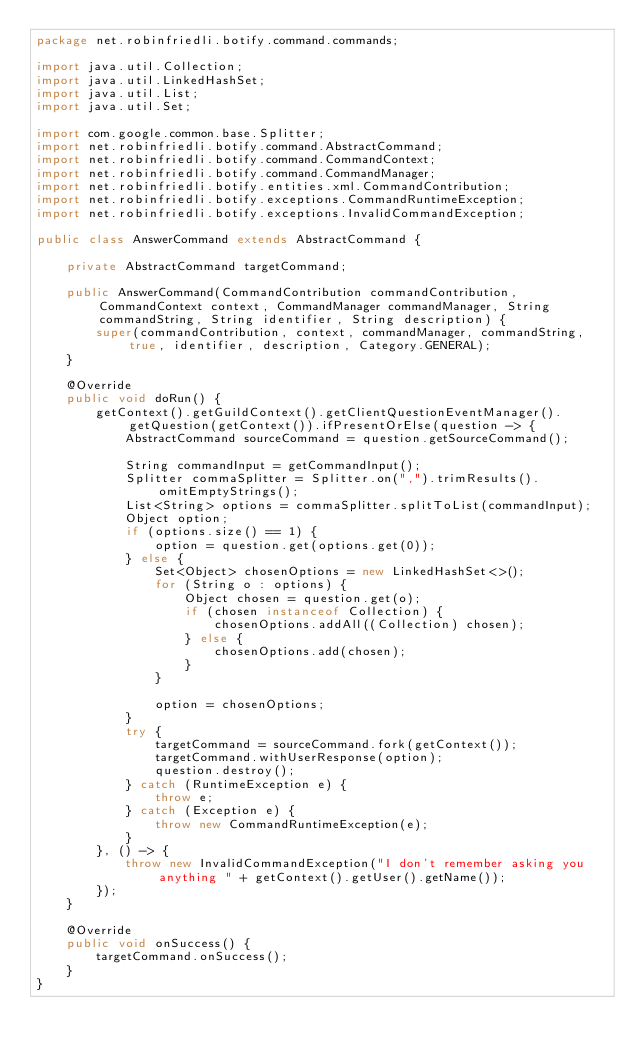<code> <loc_0><loc_0><loc_500><loc_500><_Java_>package net.robinfriedli.botify.command.commands;

import java.util.Collection;
import java.util.LinkedHashSet;
import java.util.List;
import java.util.Set;

import com.google.common.base.Splitter;
import net.robinfriedli.botify.command.AbstractCommand;
import net.robinfriedli.botify.command.CommandContext;
import net.robinfriedli.botify.command.CommandManager;
import net.robinfriedli.botify.entities.xml.CommandContribution;
import net.robinfriedli.botify.exceptions.CommandRuntimeException;
import net.robinfriedli.botify.exceptions.InvalidCommandException;

public class AnswerCommand extends AbstractCommand {

    private AbstractCommand targetCommand;

    public AnswerCommand(CommandContribution commandContribution, CommandContext context, CommandManager commandManager, String commandString, String identifier, String description) {
        super(commandContribution, context, commandManager, commandString, true, identifier, description, Category.GENERAL);
    }

    @Override
    public void doRun() {
        getContext().getGuildContext().getClientQuestionEventManager().getQuestion(getContext()).ifPresentOrElse(question -> {
            AbstractCommand sourceCommand = question.getSourceCommand();

            String commandInput = getCommandInput();
            Splitter commaSplitter = Splitter.on(",").trimResults().omitEmptyStrings();
            List<String> options = commaSplitter.splitToList(commandInput);
            Object option;
            if (options.size() == 1) {
                option = question.get(options.get(0));
            } else {
                Set<Object> chosenOptions = new LinkedHashSet<>();
                for (String o : options) {
                    Object chosen = question.get(o);
                    if (chosen instanceof Collection) {
                        chosenOptions.addAll((Collection) chosen);
                    } else {
                        chosenOptions.add(chosen);
                    }
                }

                option = chosenOptions;
            }
            try {
                targetCommand = sourceCommand.fork(getContext());
                targetCommand.withUserResponse(option);
                question.destroy();
            } catch (RuntimeException e) {
                throw e;
            } catch (Exception e) {
                throw new CommandRuntimeException(e);
            }
        }, () -> {
            throw new InvalidCommandException("I don't remember asking you anything " + getContext().getUser().getName());
        });
    }

    @Override
    public void onSuccess() {
        targetCommand.onSuccess();
    }
}
</code> 